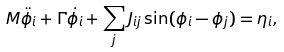Convert formula to latex. <formula><loc_0><loc_0><loc_500><loc_500>M \ddot { \phi _ { i } } + \Gamma \dot { \phi _ { i } } + \sum _ { j } J _ { i j } \sin ( \phi _ { i } - \phi _ { j } ) = \eta _ { i } ,</formula> 